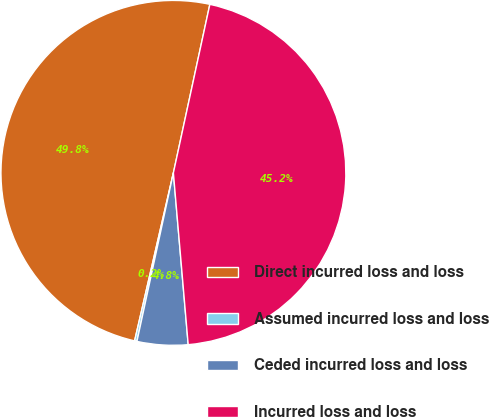Convert chart to OTSL. <chart><loc_0><loc_0><loc_500><loc_500><pie_chart><fcel>Direct incurred loss and loss<fcel>Assumed incurred loss and loss<fcel>Ceded incurred loss and loss<fcel>Incurred loss and loss<nl><fcel>49.78%<fcel>0.22%<fcel>4.76%<fcel>45.24%<nl></chart> 